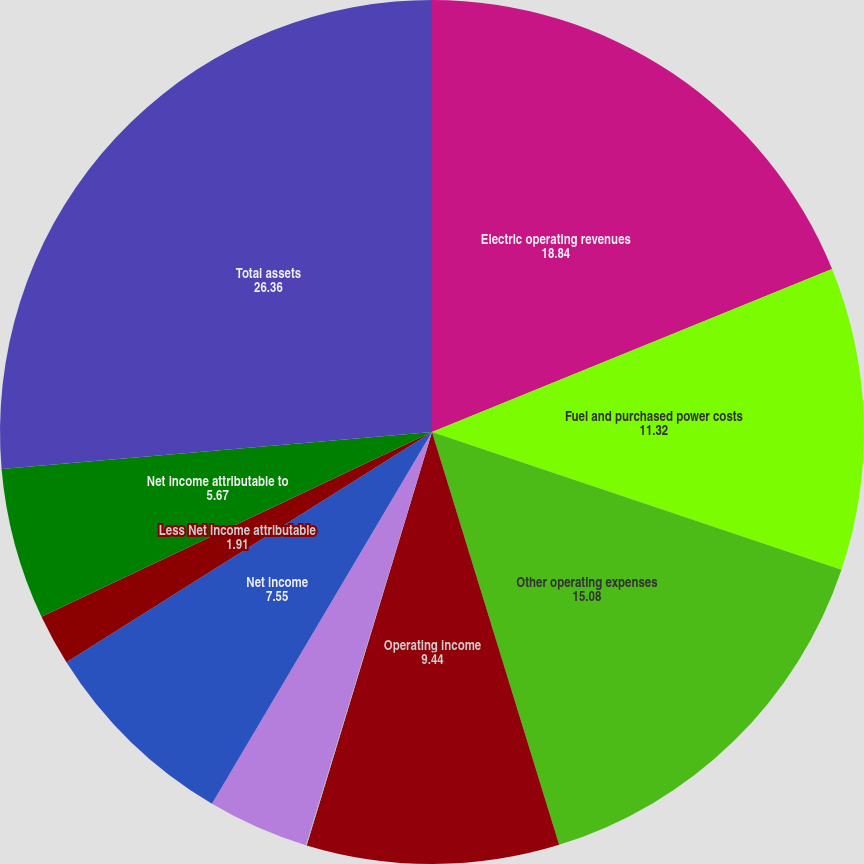<chart> <loc_0><loc_0><loc_500><loc_500><pie_chart><fcel>Electric operating revenues<fcel>Fuel and purchased power costs<fcel>Other operating expenses<fcel>Operating income<fcel>Other income<fcel>Interest expense - net of<fcel>Net income<fcel>Less Net income attributable<fcel>Net income attributable to<fcel>Total assets<nl><fcel>18.84%<fcel>11.32%<fcel>15.08%<fcel>9.44%<fcel>0.03%<fcel>3.79%<fcel>7.55%<fcel>1.91%<fcel>5.67%<fcel>26.36%<nl></chart> 